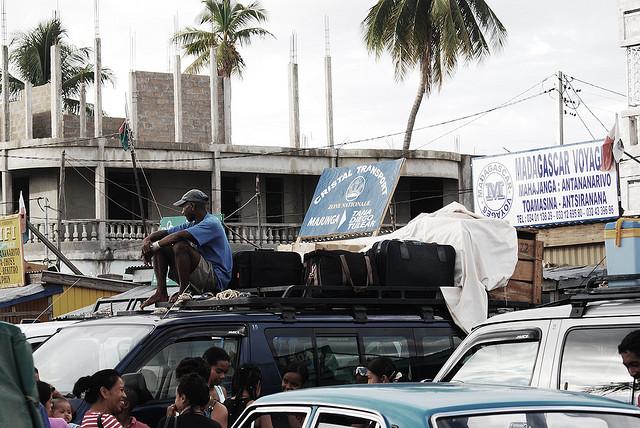What vehicle are the canine's in?
Be succinct. Car. What are the people looking at?
Short answer required. Each other. How many palm trees are pictured?
Write a very short answer. 3. What color is the SUV?
Give a very brief answer. Blue. Do you see a motorcycle?
Write a very short answer. No. Is this location in the tropics?
Concise answer only. Yes. Why is the man on the vehicles roof?
Short answer required. Sitting. What is the advertisement behind the bus?
Be succinct. Madagascar voyages. What color are the signs?
Be succinct. Blue and white. 